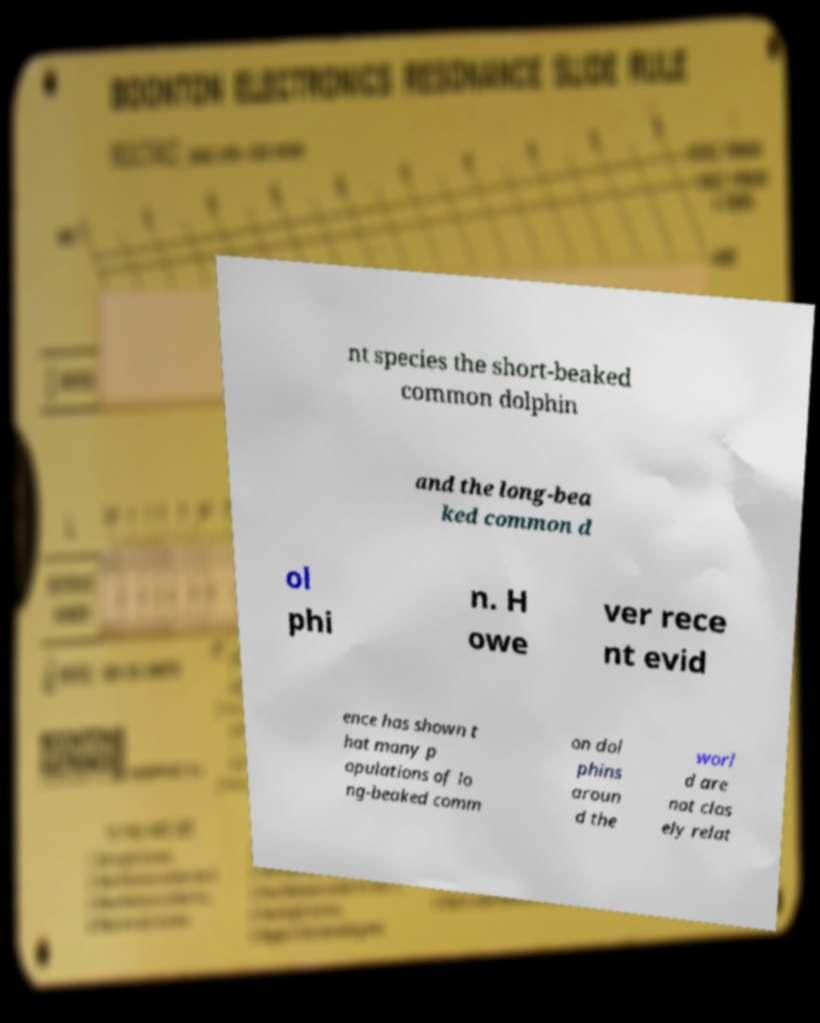I need the written content from this picture converted into text. Can you do that? nt species the short-beaked common dolphin and the long-bea ked common d ol phi n. H owe ver rece nt evid ence has shown t hat many p opulations of lo ng-beaked comm on dol phins aroun d the worl d are not clos ely relat 